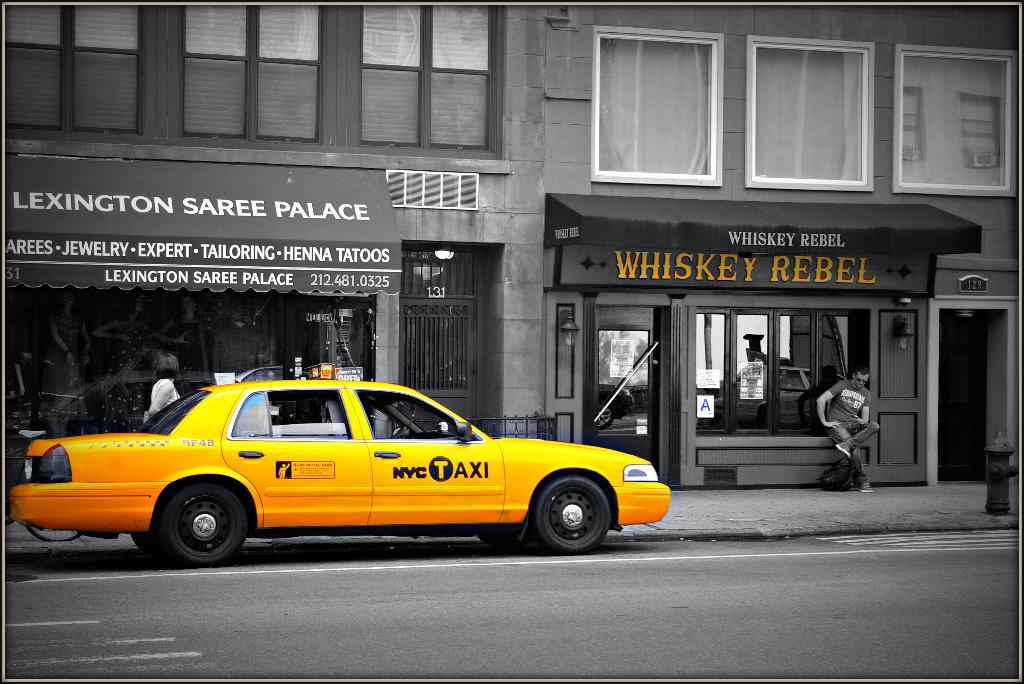Provide a one-sentence caption for the provided image. A taxi parked in front of Lexington Saree Palace. 